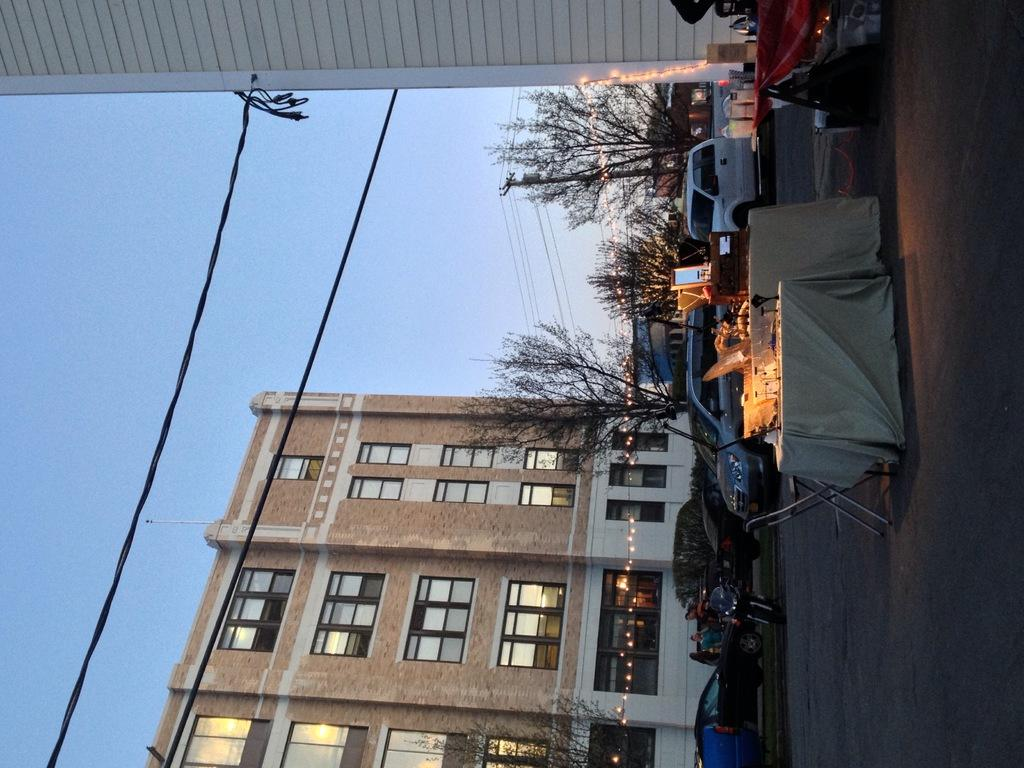What type of furniture is present in the image? There is a chair and a table in the image. What else can be seen in the image besides the furniture? Cars, a building, the sky, and trees are visible in the image. Where is the building located in the image? The building is in the middle of the image. What is visible in the sky in the image? The sky is visible in the image. What number is written on the chair in the image? There is no number written on the chair in the image. What type of reward can be seen in the room in the image? There is no room or reward present in the image. 